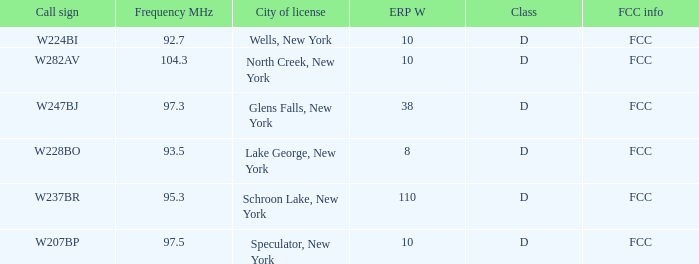Name the FCC info for frequency Mhz less than 97.3 and call sign of w237br FCC. 